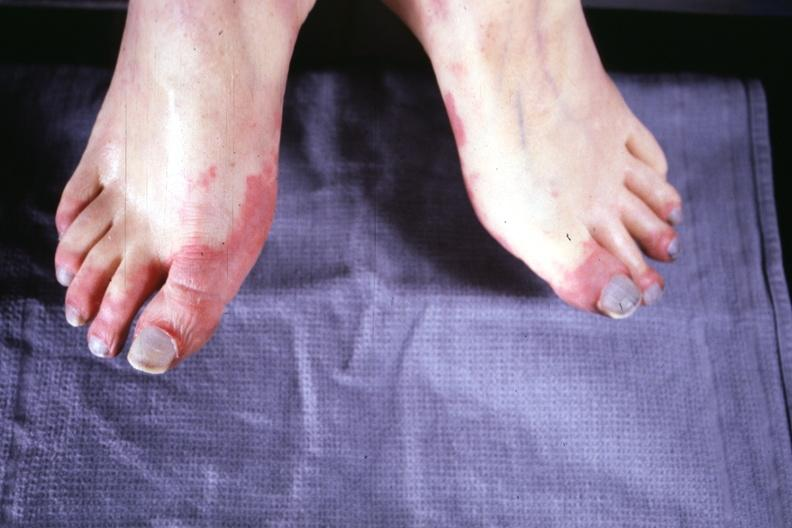re extremities present?
Answer the question using a single word or phrase. Yes 